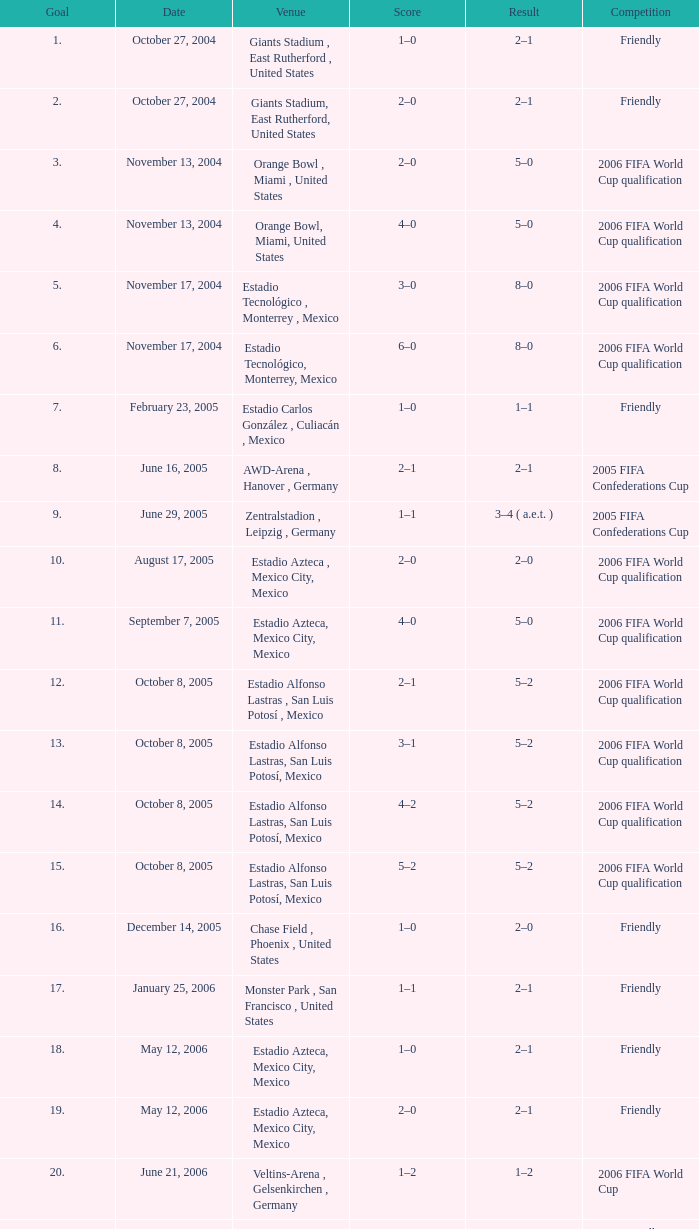Which Result has a Score of 1–0, and a Goal of 16? 2–0. 